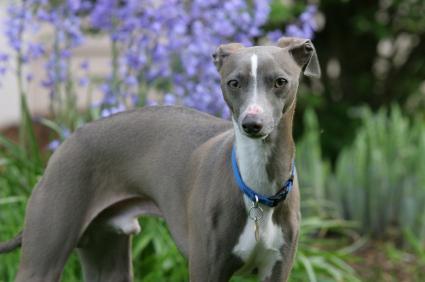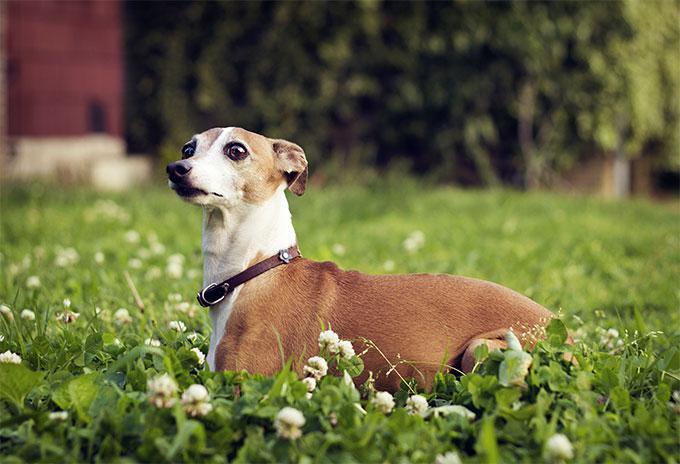The first image is the image on the left, the second image is the image on the right. For the images shown, is this caption "Both of the dogs are wearing collars." true? Answer yes or no. Yes. 